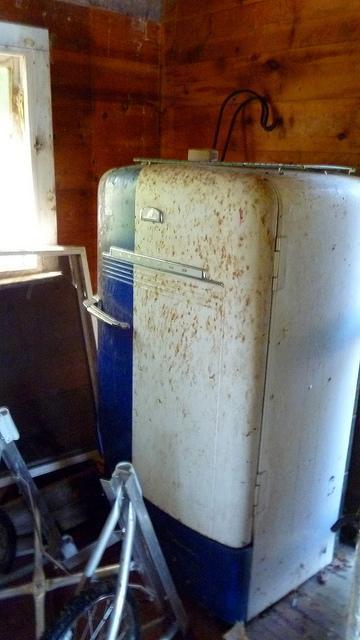How many kites are in the sky?
Give a very brief answer. 0. 